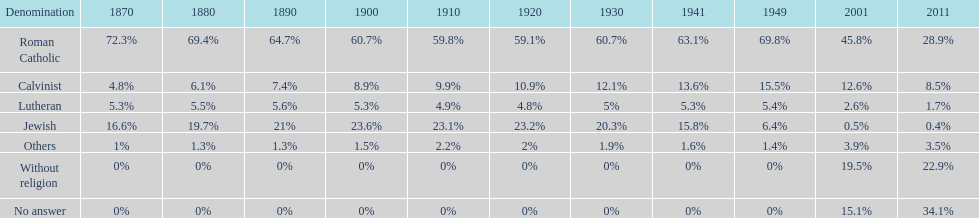Which religious denomination had a higher percentage in 1900, jewish or roman catholic? Roman Catholic. 